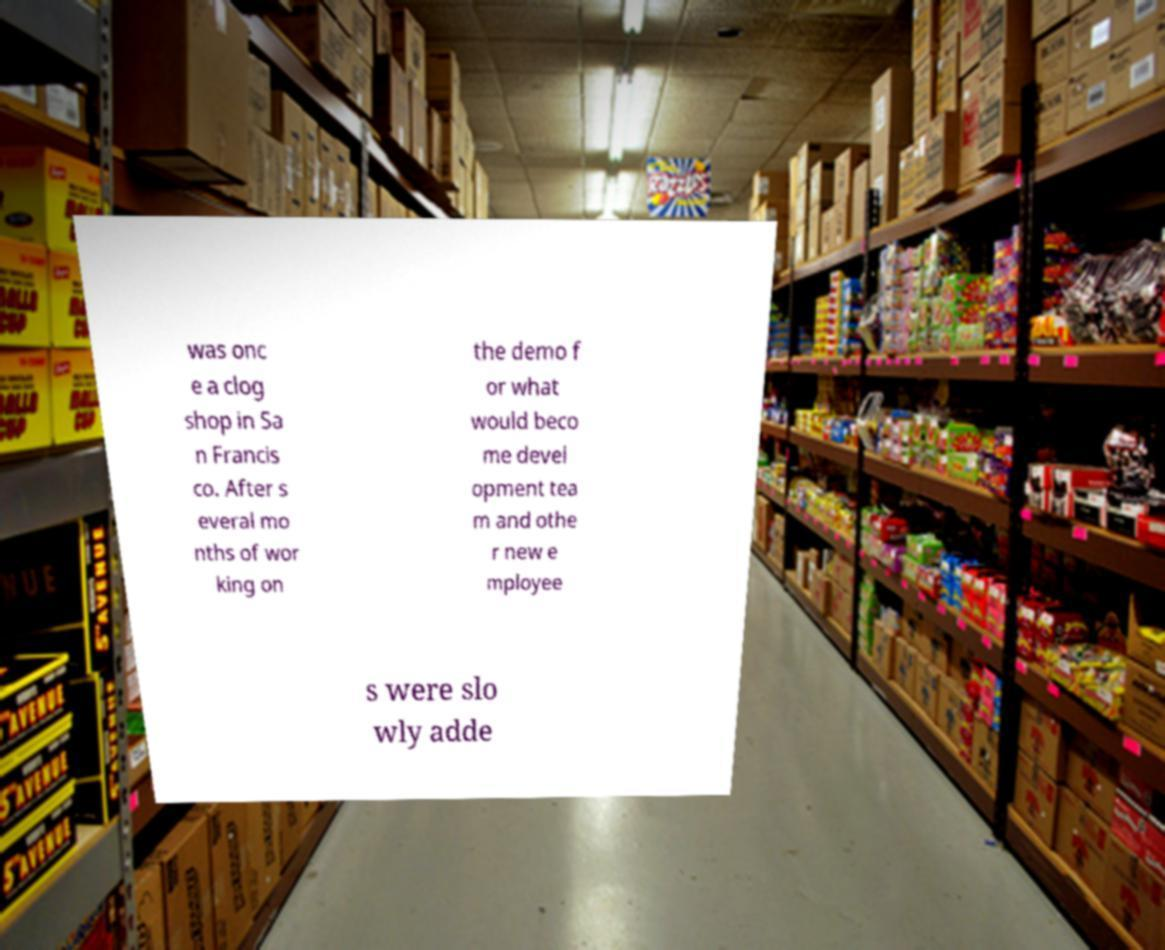Can you read and provide the text displayed in the image?This photo seems to have some interesting text. Can you extract and type it out for me? was onc e a clog shop in Sa n Francis co. After s everal mo nths of wor king on the demo f or what would beco me devel opment tea m and othe r new e mployee s were slo wly adde 